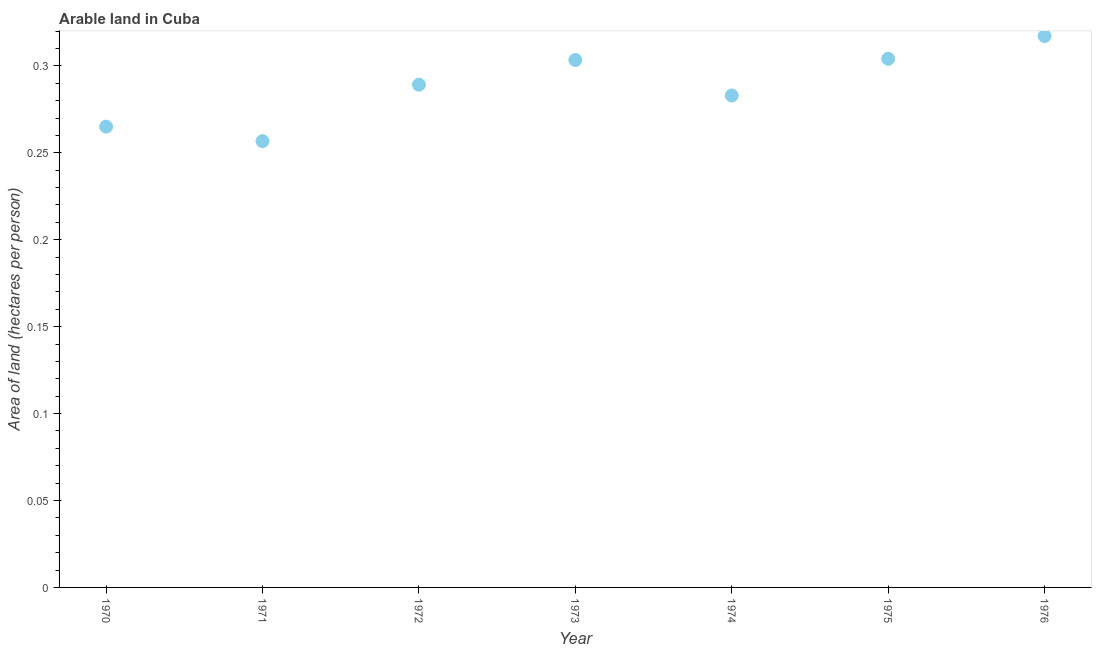What is the area of arable land in 1976?
Offer a very short reply. 0.32. Across all years, what is the maximum area of arable land?
Ensure brevity in your answer.  0.32. Across all years, what is the minimum area of arable land?
Provide a short and direct response. 0.26. In which year was the area of arable land maximum?
Your response must be concise. 1976. In which year was the area of arable land minimum?
Make the answer very short. 1971. What is the sum of the area of arable land?
Offer a very short reply. 2.02. What is the difference between the area of arable land in 1975 and 1976?
Make the answer very short. -0.01. What is the average area of arable land per year?
Your answer should be compact. 0.29. What is the median area of arable land?
Your answer should be very brief. 0.29. What is the ratio of the area of arable land in 1970 to that in 1975?
Provide a short and direct response. 0.87. Is the area of arable land in 1972 less than that in 1973?
Make the answer very short. Yes. Is the difference between the area of arable land in 1970 and 1972 greater than the difference between any two years?
Offer a terse response. No. What is the difference between the highest and the second highest area of arable land?
Provide a short and direct response. 0.01. What is the difference between the highest and the lowest area of arable land?
Your answer should be compact. 0.06. In how many years, is the area of arable land greater than the average area of arable land taken over all years?
Ensure brevity in your answer.  4. What is the difference between two consecutive major ticks on the Y-axis?
Your answer should be compact. 0.05. Are the values on the major ticks of Y-axis written in scientific E-notation?
Your response must be concise. No. Does the graph contain grids?
Offer a terse response. No. What is the title of the graph?
Your response must be concise. Arable land in Cuba. What is the label or title of the X-axis?
Provide a short and direct response. Year. What is the label or title of the Y-axis?
Keep it short and to the point. Area of land (hectares per person). What is the Area of land (hectares per person) in 1970?
Your answer should be very brief. 0.27. What is the Area of land (hectares per person) in 1971?
Provide a short and direct response. 0.26. What is the Area of land (hectares per person) in 1972?
Give a very brief answer. 0.29. What is the Area of land (hectares per person) in 1973?
Offer a terse response. 0.3. What is the Area of land (hectares per person) in 1974?
Give a very brief answer. 0.28. What is the Area of land (hectares per person) in 1975?
Provide a short and direct response. 0.3. What is the Area of land (hectares per person) in 1976?
Ensure brevity in your answer.  0.32. What is the difference between the Area of land (hectares per person) in 1970 and 1971?
Your response must be concise. 0.01. What is the difference between the Area of land (hectares per person) in 1970 and 1972?
Make the answer very short. -0.02. What is the difference between the Area of land (hectares per person) in 1970 and 1973?
Give a very brief answer. -0.04. What is the difference between the Area of land (hectares per person) in 1970 and 1974?
Provide a succinct answer. -0.02. What is the difference between the Area of land (hectares per person) in 1970 and 1975?
Offer a very short reply. -0.04. What is the difference between the Area of land (hectares per person) in 1970 and 1976?
Your answer should be very brief. -0.05. What is the difference between the Area of land (hectares per person) in 1971 and 1972?
Keep it short and to the point. -0.03. What is the difference between the Area of land (hectares per person) in 1971 and 1973?
Your answer should be compact. -0.05. What is the difference between the Area of land (hectares per person) in 1971 and 1974?
Make the answer very short. -0.03. What is the difference between the Area of land (hectares per person) in 1971 and 1975?
Make the answer very short. -0.05. What is the difference between the Area of land (hectares per person) in 1971 and 1976?
Ensure brevity in your answer.  -0.06. What is the difference between the Area of land (hectares per person) in 1972 and 1973?
Keep it short and to the point. -0.01. What is the difference between the Area of land (hectares per person) in 1972 and 1974?
Ensure brevity in your answer.  0.01. What is the difference between the Area of land (hectares per person) in 1972 and 1975?
Offer a very short reply. -0.01. What is the difference between the Area of land (hectares per person) in 1972 and 1976?
Give a very brief answer. -0.03. What is the difference between the Area of land (hectares per person) in 1973 and 1974?
Provide a short and direct response. 0.02. What is the difference between the Area of land (hectares per person) in 1973 and 1975?
Your response must be concise. -0. What is the difference between the Area of land (hectares per person) in 1973 and 1976?
Give a very brief answer. -0.01. What is the difference between the Area of land (hectares per person) in 1974 and 1975?
Offer a terse response. -0.02. What is the difference between the Area of land (hectares per person) in 1974 and 1976?
Your response must be concise. -0.03. What is the difference between the Area of land (hectares per person) in 1975 and 1976?
Provide a succinct answer. -0.01. What is the ratio of the Area of land (hectares per person) in 1970 to that in 1971?
Ensure brevity in your answer.  1.03. What is the ratio of the Area of land (hectares per person) in 1970 to that in 1972?
Provide a succinct answer. 0.92. What is the ratio of the Area of land (hectares per person) in 1970 to that in 1973?
Provide a succinct answer. 0.87. What is the ratio of the Area of land (hectares per person) in 1970 to that in 1974?
Offer a very short reply. 0.94. What is the ratio of the Area of land (hectares per person) in 1970 to that in 1975?
Provide a short and direct response. 0.87. What is the ratio of the Area of land (hectares per person) in 1970 to that in 1976?
Offer a terse response. 0.84. What is the ratio of the Area of land (hectares per person) in 1971 to that in 1972?
Your answer should be compact. 0.89. What is the ratio of the Area of land (hectares per person) in 1971 to that in 1973?
Offer a terse response. 0.85. What is the ratio of the Area of land (hectares per person) in 1971 to that in 1974?
Your answer should be very brief. 0.91. What is the ratio of the Area of land (hectares per person) in 1971 to that in 1975?
Your answer should be compact. 0.84. What is the ratio of the Area of land (hectares per person) in 1971 to that in 1976?
Your answer should be very brief. 0.81. What is the ratio of the Area of land (hectares per person) in 1972 to that in 1973?
Offer a terse response. 0.95. What is the ratio of the Area of land (hectares per person) in 1972 to that in 1975?
Give a very brief answer. 0.95. What is the ratio of the Area of land (hectares per person) in 1972 to that in 1976?
Provide a succinct answer. 0.91. What is the ratio of the Area of land (hectares per person) in 1973 to that in 1974?
Your answer should be compact. 1.07. What is the ratio of the Area of land (hectares per person) in 1973 to that in 1975?
Offer a terse response. 1. What is the ratio of the Area of land (hectares per person) in 1973 to that in 1976?
Your answer should be very brief. 0.96. What is the ratio of the Area of land (hectares per person) in 1974 to that in 1976?
Give a very brief answer. 0.89. 